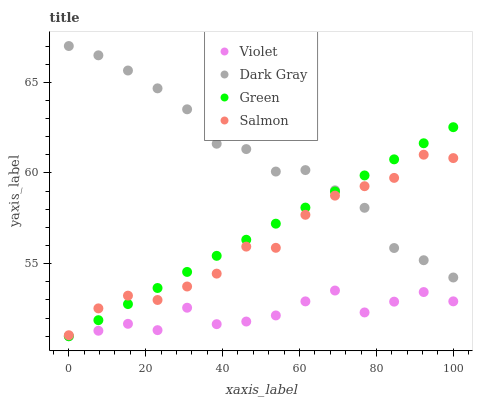Does Violet have the minimum area under the curve?
Answer yes or no. Yes. Does Dark Gray have the maximum area under the curve?
Answer yes or no. Yes. Does Salmon have the minimum area under the curve?
Answer yes or no. No. Does Salmon have the maximum area under the curve?
Answer yes or no. No. Is Green the smoothest?
Answer yes or no. Yes. Is Violet the roughest?
Answer yes or no. Yes. Is Salmon the smoothest?
Answer yes or no. No. Is Salmon the roughest?
Answer yes or no. No. Does Green have the lowest value?
Answer yes or no. Yes. Does Salmon have the lowest value?
Answer yes or no. No. Does Dark Gray have the highest value?
Answer yes or no. Yes. Does Salmon have the highest value?
Answer yes or no. No. Is Violet less than Salmon?
Answer yes or no. Yes. Is Dark Gray greater than Violet?
Answer yes or no. Yes. Does Green intersect Salmon?
Answer yes or no. Yes. Is Green less than Salmon?
Answer yes or no. No. Is Green greater than Salmon?
Answer yes or no. No. Does Violet intersect Salmon?
Answer yes or no. No. 